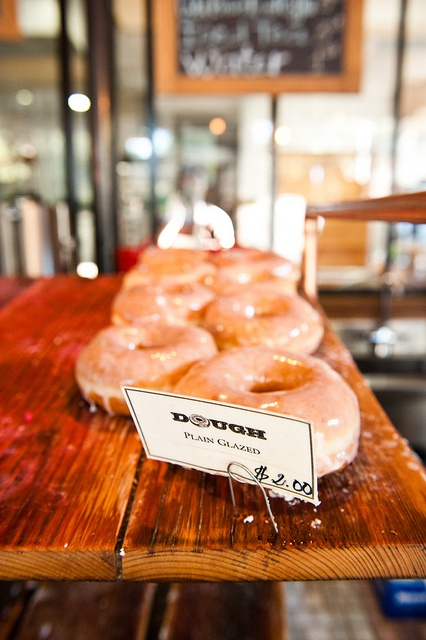Describe the objects in this image and their specific colors. I can see dining table in brown, maroon, and red tones, donut in brown, tan, orange, and ivory tones, donut in brown, tan, and red tones, donut in brown, orange, tan, and lightgray tones, and donut in brown, orange, tan, and lightgray tones in this image. 